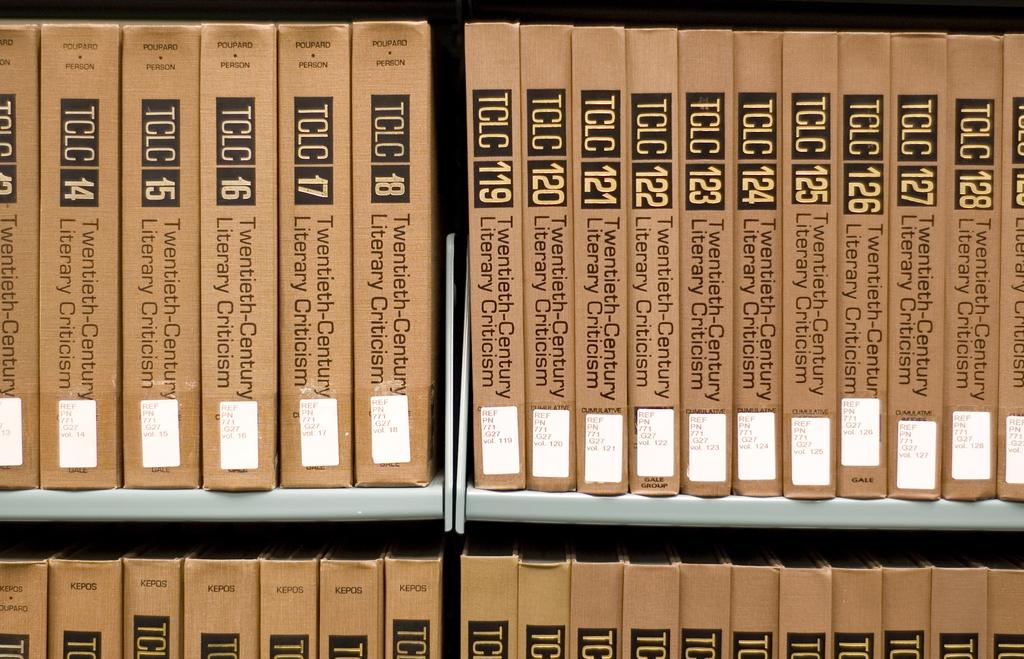<image>
Write a terse but informative summary of the picture. Many  different brown books including one that says TCLC 119. 